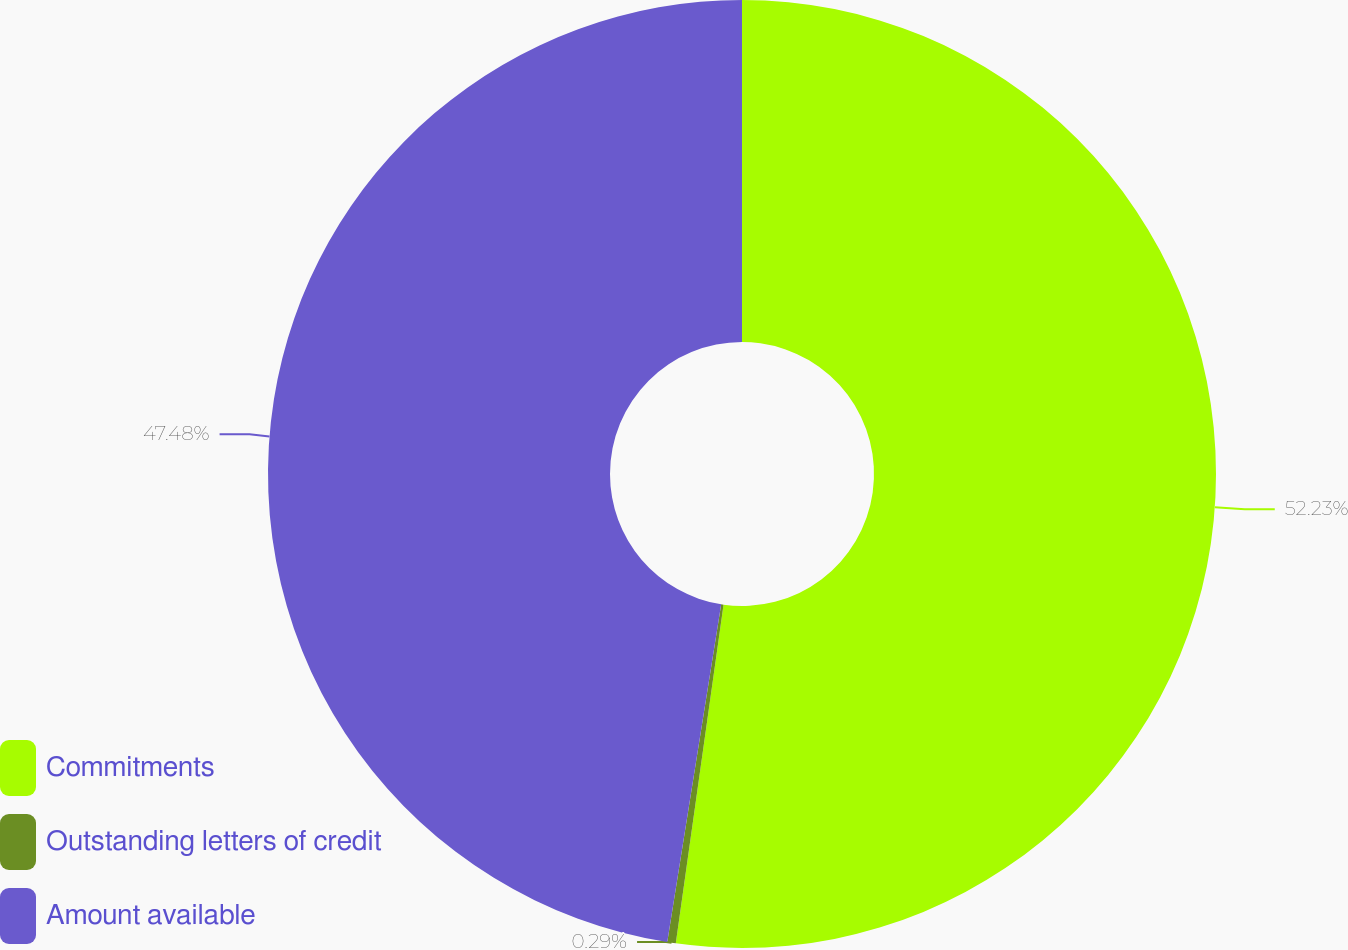Convert chart. <chart><loc_0><loc_0><loc_500><loc_500><pie_chart><fcel>Commitments<fcel>Outstanding letters of credit<fcel>Amount available<nl><fcel>52.23%<fcel>0.29%<fcel>47.48%<nl></chart> 